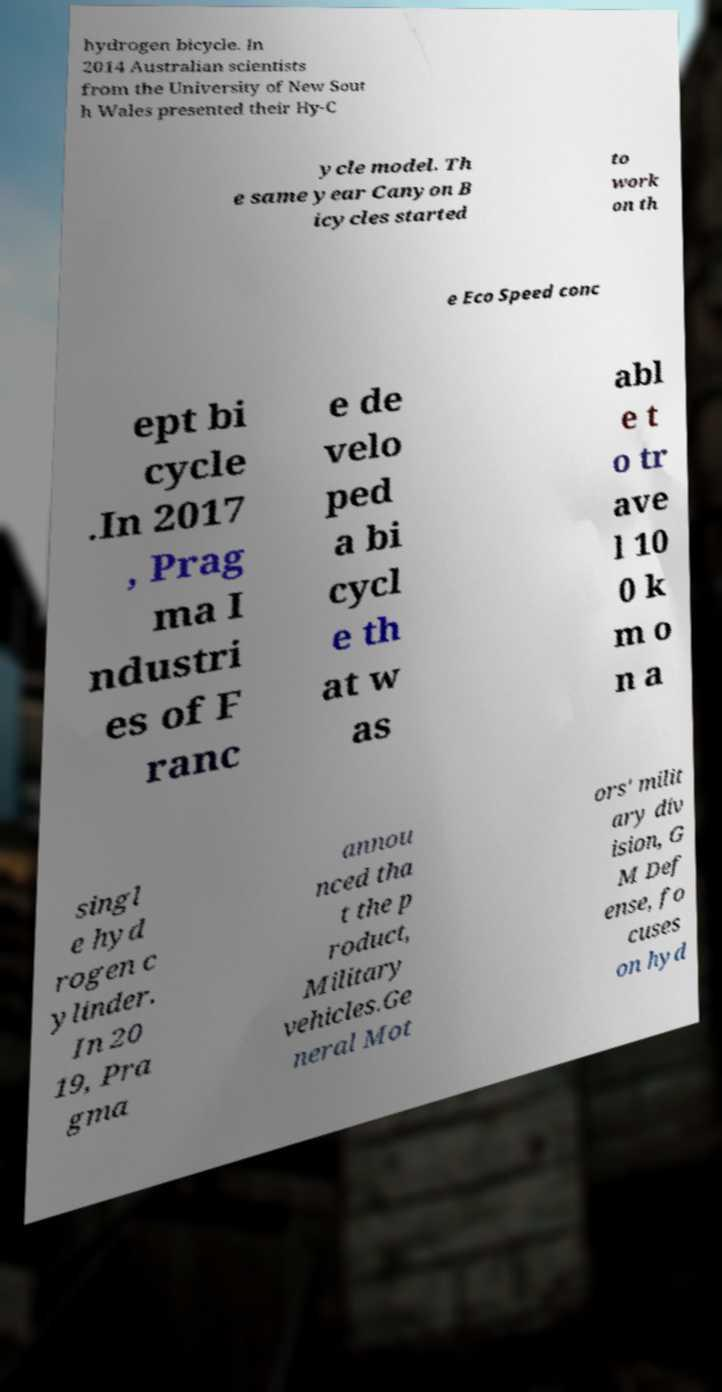Could you extract and type out the text from this image? hydrogen bicycle. In 2014 Australian scientists from the University of New Sout h Wales presented their Hy-C ycle model. Th e same year Canyon B icycles started to work on th e Eco Speed conc ept bi cycle .In 2017 , Prag ma I ndustri es of F ranc e de velo ped a bi cycl e th at w as abl e t o tr ave l 10 0 k m o n a singl e hyd rogen c ylinder. In 20 19, Pra gma annou nced tha t the p roduct, Military vehicles.Ge neral Mot ors' milit ary div ision, G M Def ense, fo cuses on hyd 